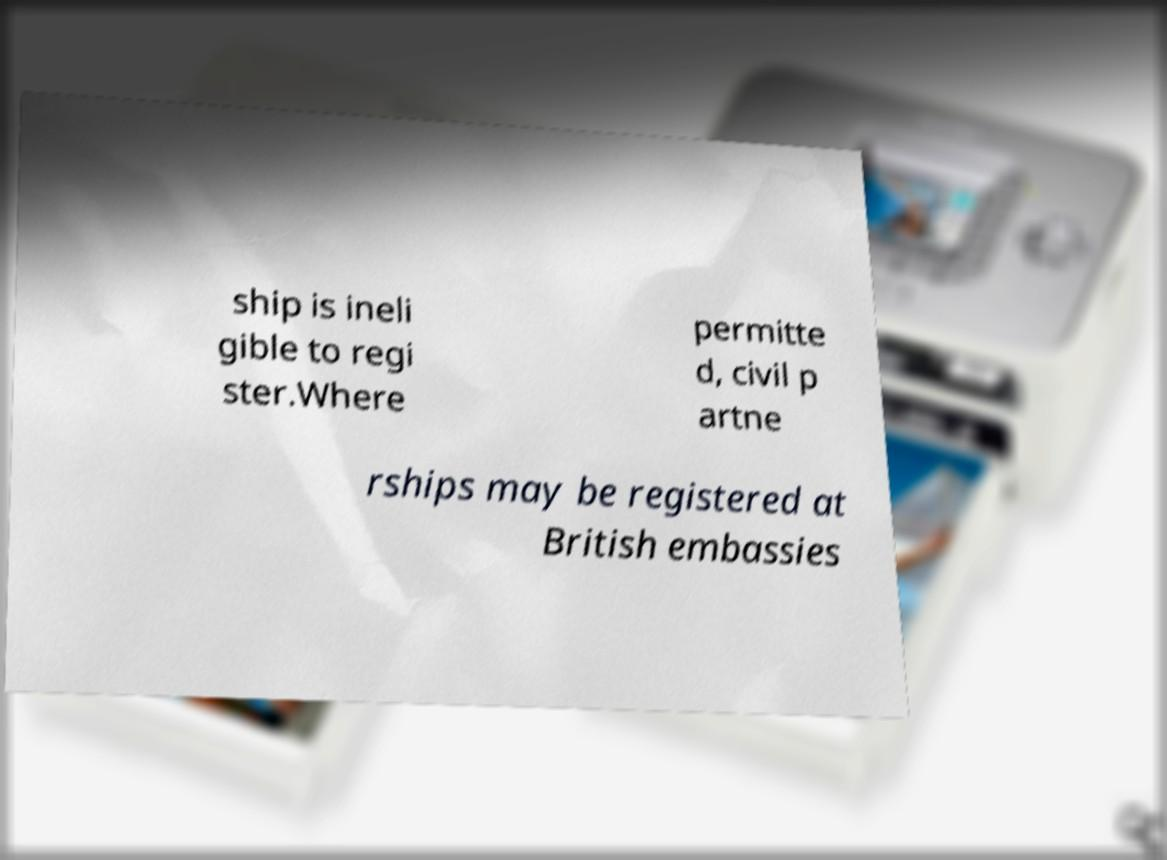Can you read and provide the text displayed in the image?This photo seems to have some interesting text. Can you extract and type it out for me? ship is ineli gible to regi ster.Where permitte d, civil p artne rships may be registered at British embassies 